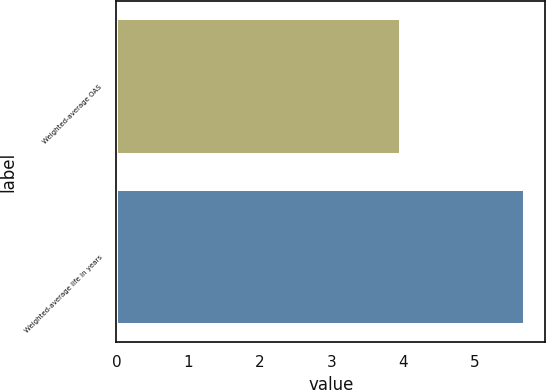Convert chart to OTSL. <chart><loc_0><loc_0><loc_500><loc_500><bar_chart><fcel>Weighted-average OAS<fcel>Weighted-average life in years<nl><fcel>3.97<fcel>5.7<nl></chart> 